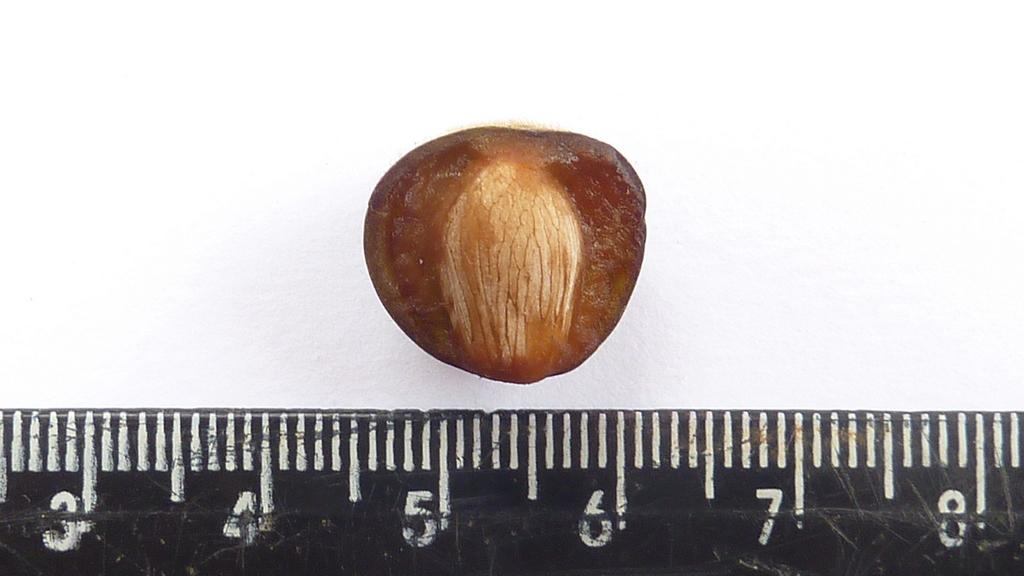What is the last number shown on the ruler?
Make the answer very short. 8. What is the first number shown on the ruler?
Give a very brief answer. 3. 